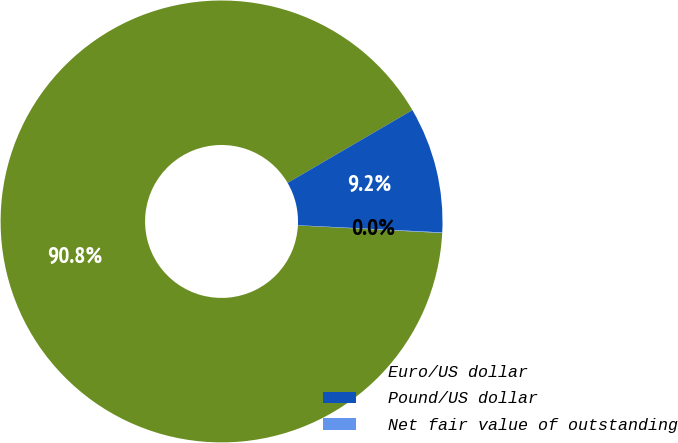<chart> <loc_0><loc_0><loc_500><loc_500><pie_chart><fcel>Euro/US dollar<fcel>Pound/US dollar<fcel>Net fair value of outstanding<nl><fcel>90.76%<fcel>9.2%<fcel>0.04%<nl></chart> 